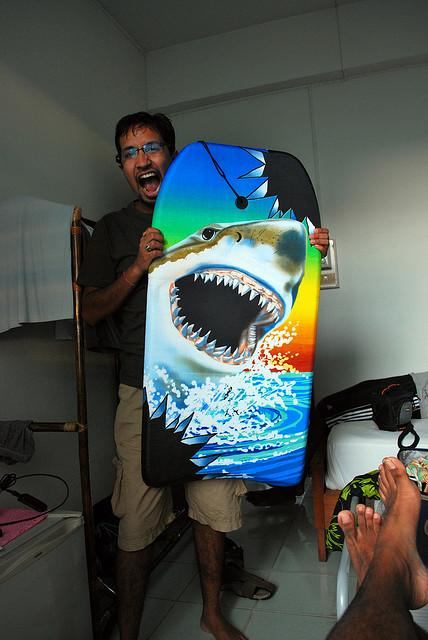What is the item being displayed by the man? Please explain your reasoning. floaty. This is a flotation board displayed by the man. 